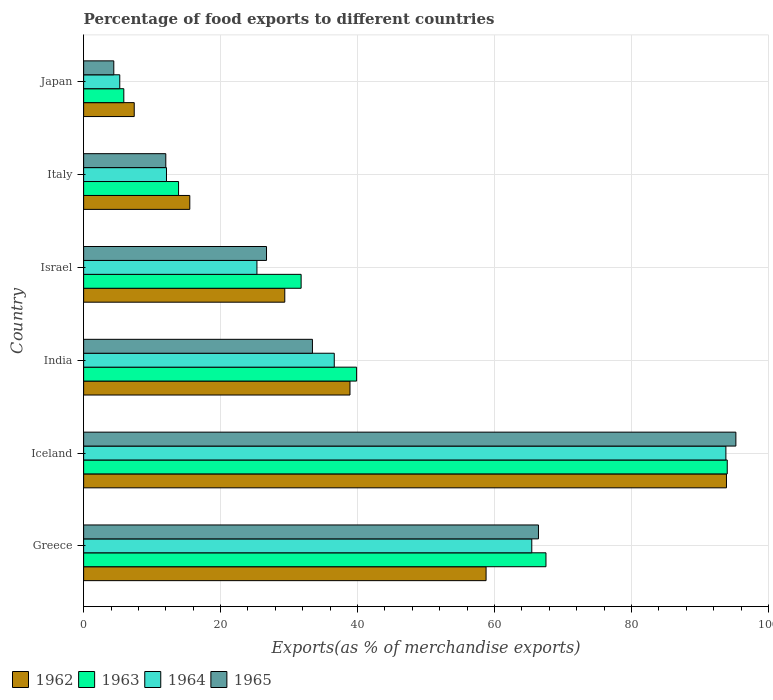How many different coloured bars are there?
Ensure brevity in your answer.  4. How many groups of bars are there?
Offer a terse response. 6. How many bars are there on the 2nd tick from the bottom?
Provide a succinct answer. 4. In how many cases, is the number of bars for a given country not equal to the number of legend labels?
Offer a terse response. 0. What is the percentage of exports to different countries in 1964 in Israel?
Ensure brevity in your answer.  25.31. Across all countries, what is the maximum percentage of exports to different countries in 1965?
Offer a terse response. 95.25. Across all countries, what is the minimum percentage of exports to different countries in 1965?
Your answer should be very brief. 4.41. What is the total percentage of exports to different countries in 1965 in the graph?
Ensure brevity in your answer.  238.2. What is the difference between the percentage of exports to different countries in 1965 in Greece and that in India?
Offer a very short reply. 33.01. What is the difference between the percentage of exports to different countries in 1965 in India and the percentage of exports to different countries in 1963 in Greece?
Your response must be concise. -34.1. What is the average percentage of exports to different countries in 1964 per country?
Your response must be concise. 39.75. What is the difference between the percentage of exports to different countries in 1962 and percentage of exports to different countries in 1964 in Greece?
Provide a short and direct response. -6.67. What is the ratio of the percentage of exports to different countries in 1963 in Greece to that in Japan?
Your answer should be very brief. 11.5. Is the percentage of exports to different countries in 1964 in Iceland less than that in Italy?
Provide a succinct answer. No. Is the difference between the percentage of exports to different countries in 1962 in Iceland and Japan greater than the difference between the percentage of exports to different countries in 1964 in Iceland and Japan?
Make the answer very short. No. What is the difference between the highest and the second highest percentage of exports to different countries in 1963?
Offer a very short reply. 26.47. What is the difference between the highest and the lowest percentage of exports to different countries in 1965?
Provide a short and direct response. 90.84. What does the 1st bar from the top in Iceland represents?
Provide a succinct answer. 1965. What does the 4th bar from the bottom in India represents?
Your answer should be compact. 1965. Is it the case that in every country, the sum of the percentage of exports to different countries in 1963 and percentage of exports to different countries in 1965 is greater than the percentage of exports to different countries in 1964?
Ensure brevity in your answer.  Yes. How many bars are there?
Make the answer very short. 24. Are the values on the major ticks of X-axis written in scientific E-notation?
Offer a terse response. No. Does the graph contain any zero values?
Your answer should be compact. No. How many legend labels are there?
Make the answer very short. 4. What is the title of the graph?
Your response must be concise. Percentage of food exports to different countries. What is the label or title of the X-axis?
Your answer should be compact. Exports(as % of merchandise exports). What is the Exports(as % of merchandise exports) of 1962 in Greece?
Keep it short and to the point. 58.77. What is the Exports(as % of merchandise exports) in 1963 in Greece?
Keep it short and to the point. 67.52. What is the Exports(as % of merchandise exports) of 1964 in Greece?
Make the answer very short. 65.45. What is the Exports(as % of merchandise exports) in 1965 in Greece?
Your answer should be compact. 66.42. What is the Exports(as % of merchandise exports) in 1962 in Iceland?
Provide a short and direct response. 93.87. What is the Exports(as % of merchandise exports) in 1963 in Iceland?
Your answer should be compact. 93.99. What is the Exports(as % of merchandise exports) of 1964 in Iceland?
Your answer should be very brief. 93.79. What is the Exports(as % of merchandise exports) in 1965 in Iceland?
Provide a succinct answer. 95.25. What is the Exports(as % of merchandise exports) in 1962 in India?
Offer a terse response. 38.9. What is the Exports(as % of merchandise exports) in 1963 in India?
Offer a terse response. 39.86. What is the Exports(as % of merchandise exports) of 1964 in India?
Your answer should be compact. 36.6. What is the Exports(as % of merchandise exports) of 1965 in India?
Your answer should be very brief. 33.41. What is the Exports(as % of merchandise exports) in 1962 in Israel?
Make the answer very short. 29.37. What is the Exports(as % of merchandise exports) in 1963 in Israel?
Your response must be concise. 31.76. What is the Exports(as % of merchandise exports) of 1964 in Israel?
Provide a short and direct response. 25.31. What is the Exports(as % of merchandise exports) in 1965 in Israel?
Ensure brevity in your answer.  26.71. What is the Exports(as % of merchandise exports) in 1962 in Italy?
Keep it short and to the point. 15.5. What is the Exports(as % of merchandise exports) in 1963 in Italy?
Your response must be concise. 13.86. What is the Exports(as % of merchandise exports) in 1964 in Italy?
Ensure brevity in your answer.  12.1. What is the Exports(as % of merchandise exports) of 1965 in Italy?
Give a very brief answer. 12. What is the Exports(as % of merchandise exports) in 1962 in Japan?
Make the answer very short. 7.39. What is the Exports(as % of merchandise exports) of 1963 in Japan?
Offer a very short reply. 5.87. What is the Exports(as % of merchandise exports) in 1964 in Japan?
Offer a very short reply. 5.28. What is the Exports(as % of merchandise exports) of 1965 in Japan?
Your answer should be very brief. 4.41. Across all countries, what is the maximum Exports(as % of merchandise exports) in 1962?
Provide a succinct answer. 93.87. Across all countries, what is the maximum Exports(as % of merchandise exports) of 1963?
Keep it short and to the point. 93.99. Across all countries, what is the maximum Exports(as % of merchandise exports) of 1964?
Provide a succinct answer. 93.79. Across all countries, what is the maximum Exports(as % of merchandise exports) of 1965?
Offer a terse response. 95.25. Across all countries, what is the minimum Exports(as % of merchandise exports) of 1962?
Ensure brevity in your answer.  7.39. Across all countries, what is the minimum Exports(as % of merchandise exports) of 1963?
Provide a succinct answer. 5.87. Across all countries, what is the minimum Exports(as % of merchandise exports) of 1964?
Your response must be concise. 5.28. Across all countries, what is the minimum Exports(as % of merchandise exports) of 1965?
Your answer should be compact. 4.41. What is the total Exports(as % of merchandise exports) of 1962 in the graph?
Offer a very short reply. 243.81. What is the total Exports(as % of merchandise exports) of 1963 in the graph?
Offer a terse response. 252.87. What is the total Exports(as % of merchandise exports) in 1964 in the graph?
Make the answer very short. 238.53. What is the total Exports(as % of merchandise exports) of 1965 in the graph?
Make the answer very short. 238.2. What is the difference between the Exports(as % of merchandise exports) of 1962 in Greece and that in Iceland?
Provide a short and direct response. -35.1. What is the difference between the Exports(as % of merchandise exports) of 1963 in Greece and that in Iceland?
Offer a terse response. -26.47. What is the difference between the Exports(as % of merchandise exports) of 1964 in Greece and that in Iceland?
Your answer should be compact. -28.35. What is the difference between the Exports(as % of merchandise exports) of 1965 in Greece and that in Iceland?
Provide a short and direct response. -28.83. What is the difference between the Exports(as % of merchandise exports) of 1962 in Greece and that in India?
Your response must be concise. 19.87. What is the difference between the Exports(as % of merchandise exports) in 1963 in Greece and that in India?
Keep it short and to the point. 27.65. What is the difference between the Exports(as % of merchandise exports) of 1964 in Greece and that in India?
Give a very brief answer. 28.84. What is the difference between the Exports(as % of merchandise exports) in 1965 in Greece and that in India?
Your answer should be very brief. 33.01. What is the difference between the Exports(as % of merchandise exports) in 1962 in Greece and that in Israel?
Make the answer very short. 29.4. What is the difference between the Exports(as % of merchandise exports) of 1963 in Greece and that in Israel?
Ensure brevity in your answer.  35.76. What is the difference between the Exports(as % of merchandise exports) in 1964 in Greece and that in Israel?
Provide a succinct answer. 40.14. What is the difference between the Exports(as % of merchandise exports) in 1965 in Greece and that in Israel?
Make the answer very short. 39.71. What is the difference between the Exports(as % of merchandise exports) in 1962 in Greece and that in Italy?
Ensure brevity in your answer.  43.27. What is the difference between the Exports(as % of merchandise exports) in 1963 in Greece and that in Italy?
Your response must be concise. 53.65. What is the difference between the Exports(as % of merchandise exports) of 1964 in Greece and that in Italy?
Provide a short and direct response. 53.35. What is the difference between the Exports(as % of merchandise exports) in 1965 in Greece and that in Italy?
Offer a terse response. 54.42. What is the difference between the Exports(as % of merchandise exports) in 1962 in Greece and that in Japan?
Give a very brief answer. 51.38. What is the difference between the Exports(as % of merchandise exports) of 1963 in Greece and that in Japan?
Keep it short and to the point. 61.65. What is the difference between the Exports(as % of merchandise exports) of 1964 in Greece and that in Japan?
Provide a short and direct response. 60.17. What is the difference between the Exports(as % of merchandise exports) of 1965 in Greece and that in Japan?
Your response must be concise. 62.01. What is the difference between the Exports(as % of merchandise exports) of 1962 in Iceland and that in India?
Ensure brevity in your answer.  54.98. What is the difference between the Exports(as % of merchandise exports) of 1963 in Iceland and that in India?
Give a very brief answer. 54.13. What is the difference between the Exports(as % of merchandise exports) in 1964 in Iceland and that in India?
Your response must be concise. 57.19. What is the difference between the Exports(as % of merchandise exports) in 1965 in Iceland and that in India?
Make the answer very short. 61.84. What is the difference between the Exports(as % of merchandise exports) of 1962 in Iceland and that in Israel?
Your answer should be compact. 64.5. What is the difference between the Exports(as % of merchandise exports) of 1963 in Iceland and that in Israel?
Your answer should be compact. 62.23. What is the difference between the Exports(as % of merchandise exports) in 1964 in Iceland and that in Israel?
Your answer should be very brief. 68.48. What is the difference between the Exports(as % of merchandise exports) of 1965 in Iceland and that in Israel?
Offer a very short reply. 68.54. What is the difference between the Exports(as % of merchandise exports) of 1962 in Iceland and that in Italy?
Provide a short and direct response. 78.37. What is the difference between the Exports(as % of merchandise exports) in 1963 in Iceland and that in Italy?
Your answer should be compact. 80.13. What is the difference between the Exports(as % of merchandise exports) in 1964 in Iceland and that in Italy?
Provide a short and direct response. 81.69. What is the difference between the Exports(as % of merchandise exports) in 1965 in Iceland and that in Italy?
Ensure brevity in your answer.  83.25. What is the difference between the Exports(as % of merchandise exports) of 1962 in Iceland and that in Japan?
Your answer should be very brief. 86.49. What is the difference between the Exports(as % of merchandise exports) in 1963 in Iceland and that in Japan?
Offer a very short reply. 88.12. What is the difference between the Exports(as % of merchandise exports) of 1964 in Iceland and that in Japan?
Offer a very short reply. 88.51. What is the difference between the Exports(as % of merchandise exports) of 1965 in Iceland and that in Japan?
Offer a very short reply. 90.84. What is the difference between the Exports(as % of merchandise exports) in 1962 in India and that in Israel?
Provide a short and direct response. 9.52. What is the difference between the Exports(as % of merchandise exports) in 1963 in India and that in Israel?
Provide a succinct answer. 8.1. What is the difference between the Exports(as % of merchandise exports) in 1964 in India and that in Israel?
Provide a succinct answer. 11.29. What is the difference between the Exports(as % of merchandise exports) of 1965 in India and that in Israel?
Your answer should be very brief. 6.71. What is the difference between the Exports(as % of merchandise exports) of 1962 in India and that in Italy?
Your response must be concise. 23.39. What is the difference between the Exports(as % of merchandise exports) in 1963 in India and that in Italy?
Provide a short and direct response. 26. What is the difference between the Exports(as % of merchandise exports) of 1964 in India and that in Italy?
Your answer should be compact. 24.5. What is the difference between the Exports(as % of merchandise exports) of 1965 in India and that in Italy?
Offer a terse response. 21.41. What is the difference between the Exports(as % of merchandise exports) in 1962 in India and that in Japan?
Offer a very short reply. 31.51. What is the difference between the Exports(as % of merchandise exports) of 1963 in India and that in Japan?
Keep it short and to the point. 34. What is the difference between the Exports(as % of merchandise exports) of 1964 in India and that in Japan?
Provide a succinct answer. 31.32. What is the difference between the Exports(as % of merchandise exports) of 1965 in India and that in Japan?
Offer a very short reply. 29.01. What is the difference between the Exports(as % of merchandise exports) of 1962 in Israel and that in Italy?
Your response must be concise. 13.87. What is the difference between the Exports(as % of merchandise exports) in 1963 in Israel and that in Italy?
Make the answer very short. 17.9. What is the difference between the Exports(as % of merchandise exports) in 1964 in Israel and that in Italy?
Provide a short and direct response. 13.21. What is the difference between the Exports(as % of merchandise exports) of 1965 in Israel and that in Italy?
Give a very brief answer. 14.71. What is the difference between the Exports(as % of merchandise exports) in 1962 in Israel and that in Japan?
Provide a short and direct response. 21.98. What is the difference between the Exports(as % of merchandise exports) in 1963 in Israel and that in Japan?
Give a very brief answer. 25.89. What is the difference between the Exports(as % of merchandise exports) of 1964 in Israel and that in Japan?
Keep it short and to the point. 20.03. What is the difference between the Exports(as % of merchandise exports) in 1965 in Israel and that in Japan?
Give a very brief answer. 22.3. What is the difference between the Exports(as % of merchandise exports) of 1962 in Italy and that in Japan?
Provide a short and direct response. 8.11. What is the difference between the Exports(as % of merchandise exports) in 1963 in Italy and that in Japan?
Ensure brevity in your answer.  8. What is the difference between the Exports(as % of merchandise exports) of 1964 in Italy and that in Japan?
Provide a short and direct response. 6.82. What is the difference between the Exports(as % of merchandise exports) of 1965 in Italy and that in Japan?
Offer a terse response. 7.59. What is the difference between the Exports(as % of merchandise exports) of 1962 in Greece and the Exports(as % of merchandise exports) of 1963 in Iceland?
Provide a succinct answer. -35.22. What is the difference between the Exports(as % of merchandise exports) in 1962 in Greece and the Exports(as % of merchandise exports) in 1964 in Iceland?
Your response must be concise. -35.02. What is the difference between the Exports(as % of merchandise exports) of 1962 in Greece and the Exports(as % of merchandise exports) of 1965 in Iceland?
Keep it short and to the point. -36.48. What is the difference between the Exports(as % of merchandise exports) of 1963 in Greece and the Exports(as % of merchandise exports) of 1964 in Iceland?
Ensure brevity in your answer.  -26.27. What is the difference between the Exports(as % of merchandise exports) in 1963 in Greece and the Exports(as % of merchandise exports) in 1965 in Iceland?
Offer a terse response. -27.73. What is the difference between the Exports(as % of merchandise exports) of 1964 in Greece and the Exports(as % of merchandise exports) of 1965 in Iceland?
Your answer should be compact. -29.8. What is the difference between the Exports(as % of merchandise exports) in 1962 in Greece and the Exports(as % of merchandise exports) in 1963 in India?
Offer a terse response. 18.91. What is the difference between the Exports(as % of merchandise exports) in 1962 in Greece and the Exports(as % of merchandise exports) in 1964 in India?
Give a very brief answer. 22.17. What is the difference between the Exports(as % of merchandise exports) in 1962 in Greece and the Exports(as % of merchandise exports) in 1965 in India?
Your answer should be compact. 25.36. What is the difference between the Exports(as % of merchandise exports) of 1963 in Greece and the Exports(as % of merchandise exports) of 1964 in India?
Your answer should be compact. 30.92. What is the difference between the Exports(as % of merchandise exports) in 1963 in Greece and the Exports(as % of merchandise exports) in 1965 in India?
Your answer should be very brief. 34.1. What is the difference between the Exports(as % of merchandise exports) of 1964 in Greece and the Exports(as % of merchandise exports) of 1965 in India?
Give a very brief answer. 32.03. What is the difference between the Exports(as % of merchandise exports) in 1962 in Greece and the Exports(as % of merchandise exports) in 1963 in Israel?
Give a very brief answer. 27.01. What is the difference between the Exports(as % of merchandise exports) of 1962 in Greece and the Exports(as % of merchandise exports) of 1964 in Israel?
Keep it short and to the point. 33.46. What is the difference between the Exports(as % of merchandise exports) in 1962 in Greece and the Exports(as % of merchandise exports) in 1965 in Israel?
Offer a terse response. 32.06. What is the difference between the Exports(as % of merchandise exports) of 1963 in Greece and the Exports(as % of merchandise exports) of 1964 in Israel?
Ensure brevity in your answer.  42.21. What is the difference between the Exports(as % of merchandise exports) of 1963 in Greece and the Exports(as % of merchandise exports) of 1965 in Israel?
Give a very brief answer. 40.81. What is the difference between the Exports(as % of merchandise exports) of 1964 in Greece and the Exports(as % of merchandise exports) of 1965 in Israel?
Ensure brevity in your answer.  38.74. What is the difference between the Exports(as % of merchandise exports) of 1962 in Greece and the Exports(as % of merchandise exports) of 1963 in Italy?
Offer a terse response. 44.91. What is the difference between the Exports(as % of merchandise exports) of 1962 in Greece and the Exports(as % of merchandise exports) of 1964 in Italy?
Make the answer very short. 46.67. What is the difference between the Exports(as % of merchandise exports) in 1962 in Greece and the Exports(as % of merchandise exports) in 1965 in Italy?
Provide a succinct answer. 46.77. What is the difference between the Exports(as % of merchandise exports) of 1963 in Greece and the Exports(as % of merchandise exports) of 1964 in Italy?
Give a very brief answer. 55.42. What is the difference between the Exports(as % of merchandise exports) of 1963 in Greece and the Exports(as % of merchandise exports) of 1965 in Italy?
Keep it short and to the point. 55.52. What is the difference between the Exports(as % of merchandise exports) in 1964 in Greece and the Exports(as % of merchandise exports) in 1965 in Italy?
Provide a short and direct response. 53.45. What is the difference between the Exports(as % of merchandise exports) in 1962 in Greece and the Exports(as % of merchandise exports) in 1963 in Japan?
Make the answer very short. 52.9. What is the difference between the Exports(as % of merchandise exports) in 1962 in Greece and the Exports(as % of merchandise exports) in 1964 in Japan?
Offer a very short reply. 53.49. What is the difference between the Exports(as % of merchandise exports) in 1962 in Greece and the Exports(as % of merchandise exports) in 1965 in Japan?
Offer a terse response. 54.36. What is the difference between the Exports(as % of merchandise exports) in 1963 in Greece and the Exports(as % of merchandise exports) in 1964 in Japan?
Your response must be concise. 62.24. What is the difference between the Exports(as % of merchandise exports) of 1963 in Greece and the Exports(as % of merchandise exports) of 1965 in Japan?
Your answer should be compact. 63.11. What is the difference between the Exports(as % of merchandise exports) in 1964 in Greece and the Exports(as % of merchandise exports) in 1965 in Japan?
Give a very brief answer. 61.04. What is the difference between the Exports(as % of merchandise exports) of 1962 in Iceland and the Exports(as % of merchandise exports) of 1963 in India?
Offer a terse response. 54.01. What is the difference between the Exports(as % of merchandise exports) of 1962 in Iceland and the Exports(as % of merchandise exports) of 1964 in India?
Your response must be concise. 57.27. What is the difference between the Exports(as % of merchandise exports) in 1962 in Iceland and the Exports(as % of merchandise exports) in 1965 in India?
Offer a terse response. 60.46. What is the difference between the Exports(as % of merchandise exports) of 1963 in Iceland and the Exports(as % of merchandise exports) of 1964 in India?
Offer a very short reply. 57.39. What is the difference between the Exports(as % of merchandise exports) of 1963 in Iceland and the Exports(as % of merchandise exports) of 1965 in India?
Keep it short and to the point. 60.58. What is the difference between the Exports(as % of merchandise exports) in 1964 in Iceland and the Exports(as % of merchandise exports) in 1965 in India?
Keep it short and to the point. 60.38. What is the difference between the Exports(as % of merchandise exports) of 1962 in Iceland and the Exports(as % of merchandise exports) of 1963 in Israel?
Your response must be concise. 62.11. What is the difference between the Exports(as % of merchandise exports) in 1962 in Iceland and the Exports(as % of merchandise exports) in 1964 in Israel?
Make the answer very short. 68.57. What is the difference between the Exports(as % of merchandise exports) of 1962 in Iceland and the Exports(as % of merchandise exports) of 1965 in Israel?
Your response must be concise. 67.17. What is the difference between the Exports(as % of merchandise exports) in 1963 in Iceland and the Exports(as % of merchandise exports) in 1964 in Israel?
Give a very brief answer. 68.68. What is the difference between the Exports(as % of merchandise exports) in 1963 in Iceland and the Exports(as % of merchandise exports) in 1965 in Israel?
Offer a terse response. 67.28. What is the difference between the Exports(as % of merchandise exports) in 1964 in Iceland and the Exports(as % of merchandise exports) in 1965 in Israel?
Ensure brevity in your answer.  67.08. What is the difference between the Exports(as % of merchandise exports) of 1962 in Iceland and the Exports(as % of merchandise exports) of 1963 in Italy?
Keep it short and to the point. 80.01. What is the difference between the Exports(as % of merchandise exports) in 1962 in Iceland and the Exports(as % of merchandise exports) in 1964 in Italy?
Your response must be concise. 81.78. What is the difference between the Exports(as % of merchandise exports) in 1962 in Iceland and the Exports(as % of merchandise exports) in 1965 in Italy?
Your response must be concise. 81.88. What is the difference between the Exports(as % of merchandise exports) of 1963 in Iceland and the Exports(as % of merchandise exports) of 1964 in Italy?
Keep it short and to the point. 81.89. What is the difference between the Exports(as % of merchandise exports) of 1963 in Iceland and the Exports(as % of merchandise exports) of 1965 in Italy?
Ensure brevity in your answer.  81.99. What is the difference between the Exports(as % of merchandise exports) in 1964 in Iceland and the Exports(as % of merchandise exports) in 1965 in Italy?
Offer a very short reply. 81.79. What is the difference between the Exports(as % of merchandise exports) in 1962 in Iceland and the Exports(as % of merchandise exports) in 1963 in Japan?
Ensure brevity in your answer.  88.01. What is the difference between the Exports(as % of merchandise exports) of 1962 in Iceland and the Exports(as % of merchandise exports) of 1964 in Japan?
Ensure brevity in your answer.  88.6. What is the difference between the Exports(as % of merchandise exports) of 1962 in Iceland and the Exports(as % of merchandise exports) of 1965 in Japan?
Your answer should be compact. 89.47. What is the difference between the Exports(as % of merchandise exports) of 1963 in Iceland and the Exports(as % of merchandise exports) of 1964 in Japan?
Make the answer very short. 88.71. What is the difference between the Exports(as % of merchandise exports) in 1963 in Iceland and the Exports(as % of merchandise exports) in 1965 in Japan?
Ensure brevity in your answer.  89.58. What is the difference between the Exports(as % of merchandise exports) of 1964 in Iceland and the Exports(as % of merchandise exports) of 1965 in Japan?
Keep it short and to the point. 89.38. What is the difference between the Exports(as % of merchandise exports) of 1962 in India and the Exports(as % of merchandise exports) of 1963 in Israel?
Offer a very short reply. 7.14. What is the difference between the Exports(as % of merchandise exports) in 1962 in India and the Exports(as % of merchandise exports) in 1964 in Israel?
Offer a very short reply. 13.59. What is the difference between the Exports(as % of merchandise exports) in 1962 in India and the Exports(as % of merchandise exports) in 1965 in Israel?
Provide a short and direct response. 12.19. What is the difference between the Exports(as % of merchandise exports) in 1963 in India and the Exports(as % of merchandise exports) in 1964 in Israel?
Make the answer very short. 14.56. What is the difference between the Exports(as % of merchandise exports) in 1963 in India and the Exports(as % of merchandise exports) in 1965 in Israel?
Provide a short and direct response. 13.16. What is the difference between the Exports(as % of merchandise exports) of 1964 in India and the Exports(as % of merchandise exports) of 1965 in Israel?
Keep it short and to the point. 9.89. What is the difference between the Exports(as % of merchandise exports) in 1962 in India and the Exports(as % of merchandise exports) in 1963 in Italy?
Make the answer very short. 25.03. What is the difference between the Exports(as % of merchandise exports) of 1962 in India and the Exports(as % of merchandise exports) of 1964 in Italy?
Offer a terse response. 26.8. What is the difference between the Exports(as % of merchandise exports) of 1962 in India and the Exports(as % of merchandise exports) of 1965 in Italy?
Make the answer very short. 26.9. What is the difference between the Exports(as % of merchandise exports) in 1963 in India and the Exports(as % of merchandise exports) in 1964 in Italy?
Your response must be concise. 27.77. What is the difference between the Exports(as % of merchandise exports) of 1963 in India and the Exports(as % of merchandise exports) of 1965 in Italy?
Give a very brief answer. 27.87. What is the difference between the Exports(as % of merchandise exports) of 1964 in India and the Exports(as % of merchandise exports) of 1965 in Italy?
Keep it short and to the point. 24.6. What is the difference between the Exports(as % of merchandise exports) in 1962 in India and the Exports(as % of merchandise exports) in 1963 in Japan?
Give a very brief answer. 33.03. What is the difference between the Exports(as % of merchandise exports) of 1962 in India and the Exports(as % of merchandise exports) of 1964 in Japan?
Provide a short and direct response. 33.62. What is the difference between the Exports(as % of merchandise exports) in 1962 in India and the Exports(as % of merchandise exports) in 1965 in Japan?
Give a very brief answer. 34.49. What is the difference between the Exports(as % of merchandise exports) in 1963 in India and the Exports(as % of merchandise exports) in 1964 in Japan?
Your answer should be compact. 34.59. What is the difference between the Exports(as % of merchandise exports) of 1963 in India and the Exports(as % of merchandise exports) of 1965 in Japan?
Keep it short and to the point. 35.46. What is the difference between the Exports(as % of merchandise exports) of 1964 in India and the Exports(as % of merchandise exports) of 1965 in Japan?
Your response must be concise. 32.2. What is the difference between the Exports(as % of merchandise exports) in 1962 in Israel and the Exports(as % of merchandise exports) in 1963 in Italy?
Your answer should be compact. 15.51. What is the difference between the Exports(as % of merchandise exports) of 1962 in Israel and the Exports(as % of merchandise exports) of 1964 in Italy?
Offer a terse response. 17.27. What is the difference between the Exports(as % of merchandise exports) of 1962 in Israel and the Exports(as % of merchandise exports) of 1965 in Italy?
Provide a short and direct response. 17.38. What is the difference between the Exports(as % of merchandise exports) of 1963 in Israel and the Exports(as % of merchandise exports) of 1964 in Italy?
Ensure brevity in your answer.  19.66. What is the difference between the Exports(as % of merchandise exports) of 1963 in Israel and the Exports(as % of merchandise exports) of 1965 in Italy?
Offer a terse response. 19.76. What is the difference between the Exports(as % of merchandise exports) in 1964 in Israel and the Exports(as % of merchandise exports) in 1965 in Italy?
Make the answer very short. 13.31. What is the difference between the Exports(as % of merchandise exports) of 1962 in Israel and the Exports(as % of merchandise exports) of 1963 in Japan?
Your response must be concise. 23.51. What is the difference between the Exports(as % of merchandise exports) of 1962 in Israel and the Exports(as % of merchandise exports) of 1964 in Japan?
Keep it short and to the point. 24.1. What is the difference between the Exports(as % of merchandise exports) of 1962 in Israel and the Exports(as % of merchandise exports) of 1965 in Japan?
Ensure brevity in your answer.  24.97. What is the difference between the Exports(as % of merchandise exports) of 1963 in Israel and the Exports(as % of merchandise exports) of 1964 in Japan?
Make the answer very short. 26.48. What is the difference between the Exports(as % of merchandise exports) of 1963 in Israel and the Exports(as % of merchandise exports) of 1965 in Japan?
Ensure brevity in your answer.  27.35. What is the difference between the Exports(as % of merchandise exports) in 1964 in Israel and the Exports(as % of merchandise exports) in 1965 in Japan?
Ensure brevity in your answer.  20.9. What is the difference between the Exports(as % of merchandise exports) of 1962 in Italy and the Exports(as % of merchandise exports) of 1963 in Japan?
Give a very brief answer. 9.63. What is the difference between the Exports(as % of merchandise exports) of 1962 in Italy and the Exports(as % of merchandise exports) of 1964 in Japan?
Give a very brief answer. 10.23. What is the difference between the Exports(as % of merchandise exports) in 1962 in Italy and the Exports(as % of merchandise exports) in 1965 in Japan?
Your response must be concise. 11.1. What is the difference between the Exports(as % of merchandise exports) of 1963 in Italy and the Exports(as % of merchandise exports) of 1964 in Japan?
Provide a succinct answer. 8.59. What is the difference between the Exports(as % of merchandise exports) of 1963 in Italy and the Exports(as % of merchandise exports) of 1965 in Japan?
Provide a succinct answer. 9.46. What is the difference between the Exports(as % of merchandise exports) in 1964 in Italy and the Exports(as % of merchandise exports) in 1965 in Japan?
Your response must be concise. 7.69. What is the average Exports(as % of merchandise exports) of 1962 per country?
Offer a terse response. 40.63. What is the average Exports(as % of merchandise exports) in 1963 per country?
Your response must be concise. 42.14. What is the average Exports(as % of merchandise exports) in 1964 per country?
Ensure brevity in your answer.  39.75. What is the average Exports(as % of merchandise exports) in 1965 per country?
Your answer should be very brief. 39.7. What is the difference between the Exports(as % of merchandise exports) of 1962 and Exports(as % of merchandise exports) of 1963 in Greece?
Your answer should be compact. -8.75. What is the difference between the Exports(as % of merchandise exports) of 1962 and Exports(as % of merchandise exports) of 1964 in Greece?
Offer a very short reply. -6.67. What is the difference between the Exports(as % of merchandise exports) of 1962 and Exports(as % of merchandise exports) of 1965 in Greece?
Provide a succinct answer. -7.65. What is the difference between the Exports(as % of merchandise exports) in 1963 and Exports(as % of merchandise exports) in 1964 in Greece?
Provide a short and direct response. 2.07. What is the difference between the Exports(as % of merchandise exports) in 1963 and Exports(as % of merchandise exports) in 1965 in Greece?
Your answer should be very brief. 1.1. What is the difference between the Exports(as % of merchandise exports) of 1964 and Exports(as % of merchandise exports) of 1965 in Greece?
Provide a succinct answer. -0.98. What is the difference between the Exports(as % of merchandise exports) in 1962 and Exports(as % of merchandise exports) in 1963 in Iceland?
Ensure brevity in your answer.  -0.12. What is the difference between the Exports(as % of merchandise exports) in 1962 and Exports(as % of merchandise exports) in 1964 in Iceland?
Provide a succinct answer. 0.08. What is the difference between the Exports(as % of merchandise exports) of 1962 and Exports(as % of merchandise exports) of 1965 in Iceland?
Give a very brief answer. -1.38. What is the difference between the Exports(as % of merchandise exports) in 1963 and Exports(as % of merchandise exports) in 1964 in Iceland?
Keep it short and to the point. 0.2. What is the difference between the Exports(as % of merchandise exports) in 1963 and Exports(as % of merchandise exports) in 1965 in Iceland?
Give a very brief answer. -1.26. What is the difference between the Exports(as % of merchandise exports) of 1964 and Exports(as % of merchandise exports) of 1965 in Iceland?
Provide a short and direct response. -1.46. What is the difference between the Exports(as % of merchandise exports) in 1962 and Exports(as % of merchandise exports) in 1963 in India?
Provide a succinct answer. -0.97. What is the difference between the Exports(as % of merchandise exports) of 1962 and Exports(as % of merchandise exports) of 1964 in India?
Give a very brief answer. 2.29. What is the difference between the Exports(as % of merchandise exports) of 1962 and Exports(as % of merchandise exports) of 1965 in India?
Provide a short and direct response. 5.48. What is the difference between the Exports(as % of merchandise exports) in 1963 and Exports(as % of merchandise exports) in 1964 in India?
Your answer should be compact. 3.26. What is the difference between the Exports(as % of merchandise exports) of 1963 and Exports(as % of merchandise exports) of 1965 in India?
Offer a terse response. 6.45. What is the difference between the Exports(as % of merchandise exports) of 1964 and Exports(as % of merchandise exports) of 1965 in India?
Make the answer very short. 3.19. What is the difference between the Exports(as % of merchandise exports) of 1962 and Exports(as % of merchandise exports) of 1963 in Israel?
Offer a terse response. -2.39. What is the difference between the Exports(as % of merchandise exports) in 1962 and Exports(as % of merchandise exports) in 1964 in Israel?
Your answer should be very brief. 4.07. What is the difference between the Exports(as % of merchandise exports) of 1962 and Exports(as % of merchandise exports) of 1965 in Israel?
Offer a terse response. 2.67. What is the difference between the Exports(as % of merchandise exports) in 1963 and Exports(as % of merchandise exports) in 1964 in Israel?
Keep it short and to the point. 6.45. What is the difference between the Exports(as % of merchandise exports) in 1963 and Exports(as % of merchandise exports) in 1965 in Israel?
Keep it short and to the point. 5.05. What is the difference between the Exports(as % of merchandise exports) in 1964 and Exports(as % of merchandise exports) in 1965 in Israel?
Your response must be concise. -1.4. What is the difference between the Exports(as % of merchandise exports) of 1962 and Exports(as % of merchandise exports) of 1963 in Italy?
Provide a succinct answer. 1.64. What is the difference between the Exports(as % of merchandise exports) in 1962 and Exports(as % of merchandise exports) in 1964 in Italy?
Make the answer very short. 3.4. What is the difference between the Exports(as % of merchandise exports) in 1962 and Exports(as % of merchandise exports) in 1965 in Italy?
Your answer should be very brief. 3.5. What is the difference between the Exports(as % of merchandise exports) of 1963 and Exports(as % of merchandise exports) of 1964 in Italy?
Your answer should be compact. 1.77. What is the difference between the Exports(as % of merchandise exports) of 1963 and Exports(as % of merchandise exports) of 1965 in Italy?
Make the answer very short. 1.87. What is the difference between the Exports(as % of merchandise exports) in 1964 and Exports(as % of merchandise exports) in 1965 in Italy?
Give a very brief answer. 0.1. What is the difference between the Exports(as % of merchandise exports) of 1962 and Exports(as % of merchandise exports) of 1963 in Japan?
Ensure brevity in your answer.  1.52. What is the difference between the Exports(as % of merchandise exports) in 1962 and Exports(as % of merchandise exports) in 1964 in Japan?
Keep it short and to the point. 2.11. What is the difference between the Exports(as % of merchandise exports) of 1962 and Exports(as % of merchandise exports) of 1965 in Japan?
Provide a succinct answer. 2.98. What is the difference between the Exports(as % of merchandise exports) of 1963 and Exports(as % of merchandise exports) of 1964 in Japan?
Give a very brief answer. 0.59. What is the difference between the Exports(as % of merchandise exports) of 1963 and Exports(as % of merchandise exports) of 1965 in Japan?
Ensure brevity in your answer.  1.46. What is the difference between the Exports(as % of merchandise exports) of 1964 and Exports(as % of merchandise exports) of 1965 in Japan?
Offer a terse response. 0.87. What is the ratio of the Exports(as % of merchandise exports) of 1962 in Greece to that in Iceland?
Offer a terse response. 0.63. What is the ratio of the Exports(as % of merchandise exports) in 1963 in Greece to that in Iceland?
Offer a terse response. 0.72. What is the ratio of the Exports(as % of merchandise exports) of 1964 in Greece to that in Iceland?
Offer a terse response. 0.7. What is the ratio of the Exports(as % of merchandise exports) of 1965 in Greece to that in Iceland?
Your response must be concise. 0.7. What is the ratio of the Exports(as % of merchandise exports) of 1962 in Greece to that in India?
Offer a terse response. 1.51. What is the ratio of the Exports(as % of merchandise exports) of 1963 in Greece to that in India?
Provide a succinct answer. 1.69. What is the ratio of the Exports(as % of merchandise exports) of 1964 in Greece to that in India?
Ensure brevity in your answer.  1.79. What is the ratio of the Exports(as % of merchandise exports) of 1965 in Greece to that in India?
Give a very brief answer. 1.99. What is the ratio of the Exports(as % of merchandise exports) in 1962 in Greece to that in Israel?
Your response must be concise. 2. What is the ratio of the Exports(as % of merchandise exports) in 1963 in Greece to that in Israel?
Provide a short and direct response. 2.13. What is the ratio of the Exports(as % of merchandise exports) of 1964 in Greece to that in Israel?
Make the answer very short. 2.59. What is the ratio of the Exports(as % of merchandise exports) of 1965 in Greece to that in Israel?
Your answer should be compact. 2.49. What is the ratio of the Exports(as % of merchandise exports) in 1962 in Greece to that in Italy?
Keep it short and to the point. 3.79. What is the ratio of the Exports(as % of merchandise exports) of 1963 in Greece to that in Italy?
Provide a short and direct response. 4.87. What is the ratio of the Exports(as % of merchandise exports) in 1964 in Greece to that in Italy?
Your response must be concise. 5.41. What is the ratio of the Exports(as % of merchandise exports) of 1965 in Greece to that in Italy?
Keep it short and to the point. 5.54. What is the ratio of the Exports(as % of merchandise exports) of 1962 in Greece to that in Japan?
Keep it short and to the point. 7.95. What is the ratio of the Exports(as % of merchandise exports) of 1963 in Greece to that in Japan?
Keep it short and to the point. 11.5. What is the ratio of the Exports(as % of merchandise exports) of 1964 in Greece to that in Japan?
Offer a very short reply. 12.4. What is the ratio of the Exports(as % of merchandise exports) in 1965 in Greece to that in Japan?
Provide a short and direct response. 15.07. What is the ratio of the Exports(as % of merchandise exports) in 1962 in Iceland to that in India?
Offer a terse response. 2.41. What is the ratio of the Exports(as % of merchandise exports) in 1963 in Iceland to that in India?
Offer a very short reply. 2.36. What is the ratio of the Exports(as % of merchandise exports) in 1964 in Iceland to that in India?
Offer a very short reply. 2.56. What is the ratio of the Exports(as % of merchandise exports) in 1965 in Iceland to that in India?
Provide a succinct answer. 2.85. What is the ratio of the Exports(as % of merchandise exports) of 1962 in Iceland to that in Israel?
Offer a terse response. 3.2. What is the ratio of the Exports(as % of merchandise exports) in 1963 in Iceland to that in Israel?
Offer a very short reply. 2.96. What is the ratio of the Exports(as % of merchandise exports) of 1964 in Iceland to that in Israel?
Give a very brief answer. 3.71. What is the ratio of the Exports(as % of merchandise exports) in 1965 in Iceland to that in Israel?
Offer a terse response. 3.57. What is the ratio of the Exports(as % of merchandise exports) of 1962 in Iceland to that in Italy?
Give a very brief answer. 6.05. What is the ratio of the Exports(as % of merchandise exports) of 1963 in Iceland to that in Italy?
Give a very brief answer. 6.78. What is the ratio of the Exports(as % of merchandise exports) in 1964 in Iceland to that in Italy?
Offer a terse response. 7.75. What is the ratio of the Exports(as % of merchandise exports) of 1965 in Iceland to that in Italy?
Make the answer very short. 7.94. What is the ratio of the Exports(as % of merchandise exports) of 1962 in Iceland to that in Japan?
Give a very brief answer. 12.7. What is the ratio of the Exports(as % of merchandise exports) in 1963 in Iceland to that in Japan?
Give a very brief answer. 16.01. What is the ratio of the Exports(as % of merchandise exports) of 1964 in Iceland to that in Japan?
Make the answer very short. 17.77. What is the ratio of the Exports(as % of merchandise exports) in 1965 in Iceland to that in Japan?
Offer a very short reply. 21.62. What is the ratio of the Exports(as % of merchandise exports) of 1962 in India to that in Israel?
Keep it short and to the point. 1.32. What is the ratio of the Exports(as % of merchandise exports) in 1963 in India to that in Israel?
Give a very brief answer. 1.26. What is the ratio of the Exports(as % of merchandise exports) of 1964 in India to that in Israel?
Your answer should be very brief. 1.45. What is the ratio of the Exports(as % of merchandise exports) of 1965 in India to that in Israel?
Provide a succinct answer. 1.25. What is the ratio of the Exports(as % of merchandise exports) in 1962 in India to that in Italy?
Ensure brevity in your answer.  2.51. What is the ratio of the Exports(as % of merchandise exports) in 1963 in India to that in Italy?
Your answer should be compact. 2.88. What is the ratio of the Exports(as % of merchandise exports) in 1964 in India to that in Italy?
Keep it short and to the point. 3.03. What is the ratio of the Exports(as % of merchandise exports) of 1965 in India to that in Italy?
Provide a short and direct response. 2.78. What is the ratio of the Exports(as % of merchandise exports) in 1962 in India to that in Japan?
Provide a succinct answer. 5.26. What is the ratio of the Exports(as % of merchandise exports) in 1963 in India to that in Japan?
Offer a terse response. 6.79. What is the ratio of the Exports(as % of merchandise exports) in 1964 in India to that in Japan?
Your answer should be compact. 6.93. What is the ratio of the Exports(as % of merchandise exports) in 1965 in India to that in Japan?
Give a very brief answer. 7.58. What is the ratio of the Exports(as % of merchandise exports) of 1962 in Israel to that in Italy?
Ensure brevity in your answer.  1.89. What is the ratio of the Exports(as % of merchandise exports) in 1963 in Israel to that in Italy?
Provide a short and direct response. 2.29. What is the ratio of the Exports(as % of merchandise exports) of 1964 in Israel to that in Italy?
Provide a short and direct response. 2.09. What is the ratio of the Exports(as % of merchandise exports) in 1965 in Israel to that in Italy?
Keep it short and to the point. 2.23. What is the ratio of the Exports(as % of merchandise exports) in 1962 in Israel to that in Japan?
Ensure brevity in your answer.  3.98. What is the ratio of the Exports(as % of merchandise exports) of 1963 in Israel to that in Japan?
Provide a succinct answer. 5.41. What is the ratio of the Exports(as % of merchandise exports) of 1964 in Israel to that in Japan?
Provide a succinct answer. 4.79. What is the ratio of the Exports(as % of merchandise exports) of 1965 in Israel to that in Japan?
Your response must be concise. 6.06. What is the ratio of the Exports(as % of merchandise exports) in 1962 in Italy to that in Japan?
Your answer should be very brief. 2.1. What is the ratio of the Exports(as % of merchandise exports) of 1963 in Italy to that in Japan?
Offer a very short reply. 2.36. What is the ratio of the Exports(as % of merchandise exports) in 1964 in Italy to that in Japan?
Your answer should be very brief. 2.29. What is the ratio of the Exports(as % of merchandise exports) in 1965 in Italy to that in Japan?
Provide a short and direct response. 2.72. What is the difference between the highest and the second highest Exports(as % of merchandise exports) in 1962?
Provide a short and direct response. 35.1. What is the difference between the highest and the second highest Exports(as % of merchandise exports) of 1963?
Offer a terse response. 26.47. What is the difference between the highest and the second highest Exports(as % of merchandise exports) in 1964?
Ensure brevity in your answer.  28.35. What is the difference between the highest and the second highest Exports(as % of merchandise exports) in 1965?
Your response must be concise. 28.83. What is the difference between the highest and the lowest Exports(as % of merchandise exports) of 1962?
Your answer should be compact. 86.49. What is the difference between the highest and the lowest Exports(as % of merchandise exports) of 1963?
Your answer should be compact. 88.12. What is the difference between the highest and the lowest Exports(as % of merchandise exports) of 1964?
Keep it short and to the point. 88.51. What is the difference between the highest and the lowest Exports(as % of merchandise exports) of 1965?
Your answer should be very brief. 90.84. 